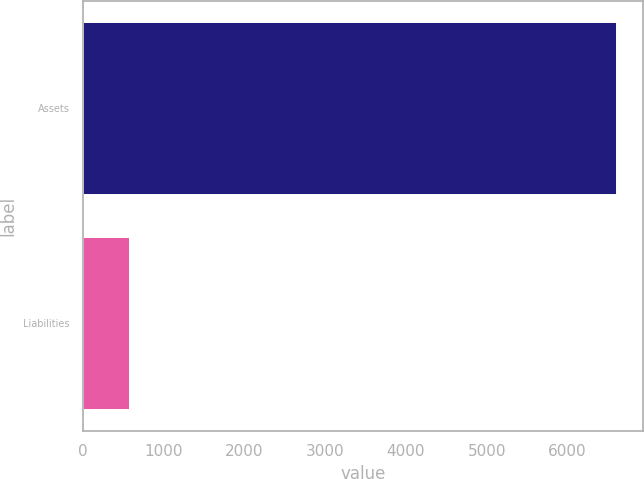Convert chart to OTSL. <chart><loc_0><loc_0><loc_500><loc_500><bar_chart><fcel>Assets<fcel>Liabilities<nl><fcel>6605<fcel>576<nl></chart> 